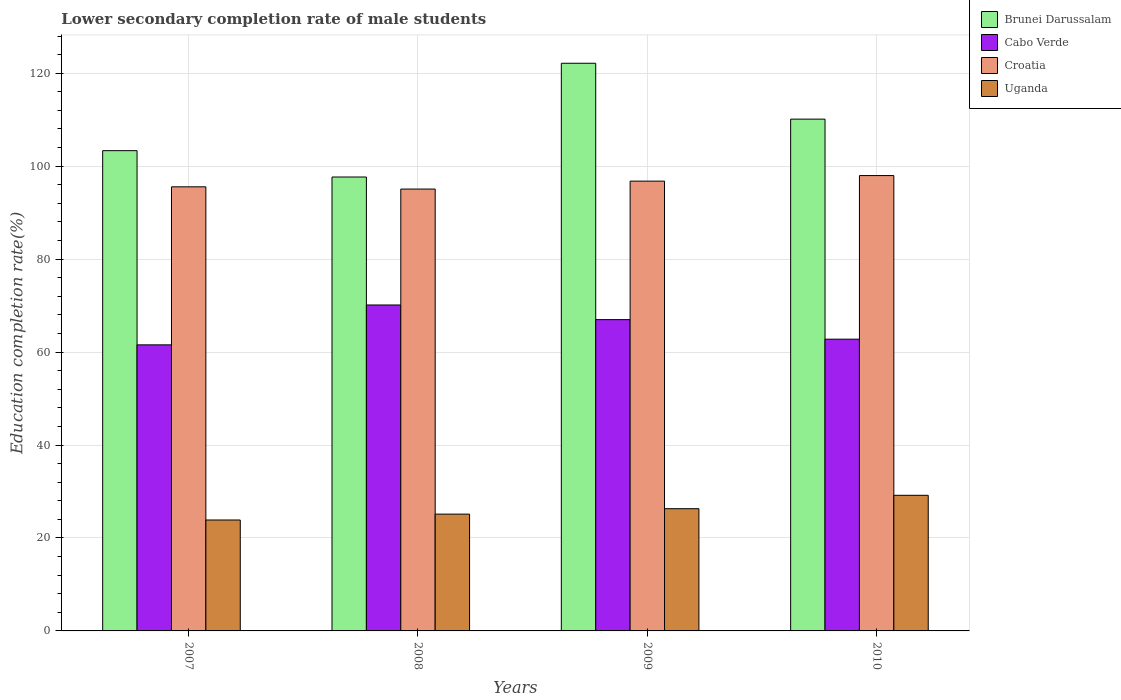Are the number of bars on each tick of the X-axis equal?
Keep it short and to the point. Yes. What is the lower secondary completion rate of male students in Cabo Verde in 2009?
Give a very brief answer. 66.98. Across all years, what is the maximum lower secondary completion rate of male students in Cabo Verde?
Offer a terse response. 70.13. Across all years, what is the minimum lower secondary completion rate of male students in Croatia?
Make the answer very short. 95.08. In which year was the lower secondary completion rate of male students in Uganda maximum?
Your answer should be very brief. 2010. In which year was the lower secondary completion rate of male students in Croatia minimum?
Your answer should be compact. 2008. What is the total lower secondary completion rate of male students in Croatia in the graph?
Your answer should be very brief. 385.39. What is the difference between the lower secondary completion rate of male students in Cabo Verde in 2007 and that in 2008?
Offer a very short reply. -8.58. What is the difference between the lower secondary completion rate of male students in Cabo Verde in 2010 and the lower secondary completion rate of male students in Brunei Darussalam in 2009?
Your answer should be compact. -59.37. What is the average lower secondary completion rate of male students in Cabo Verde per year?
Make the answer very short. 65.36. In the year 2010, what is the difference between the lower secondary completion rate of male students in Cabo Verde and lower secondary completion rate of male students in Croatia?
Offer a terse response. -35.2. What is the ratio of the lower secondary completion rate of male students in Brunei Darussalam in 2007 to that in 2010?
Keep it short and to the point. 0.94. What is the difference between the highest and the second highest lower secondary completion rate of male students in Uganda?
Provide a succinct answer. 2.88. What is the difference between the highest and the lowest lower secondary completion rate of male students in Cabo Verde?
Provide a short and direct response. 8.58. Is it the case that in every year, the sum of the lower secondary completion rate of male students in Uganda and lower secondary completion rate of male students in Croatia is greater than the sum of lower secondary completion rate of male students in Brunei Darussalam and lower secondary completion rate of male students in Cabo Verde?
Provide a succinct answer. No. What does the 3rd bar from the left in 2007 represents?
Offer a very short reply. Croatia. What does the 3rd bar from the right in 2010 represents?
Provide a succinct answer. Cabo Verde. Is it the case that in every year, the sum of the lower secondary completion rate of male students in Cabo Verde and lower secondary completion rate of male students in Croatia is greater than the lower secondary completion rate of male students in Uganda?
Your answer should be compact. Yes. How many bars are there?
Provide a succinct answer. 16. What is the difference between two consecutive major ticks on the Y-axis?
Ensure brevity in your answer.  20. Are the values on the major ticks of Y-axis written in scientific E-notation?
Your response must be concise. No. Does the graph contain grids?
Provide a short and direct response. Yes. How many legend labels are there?
Your answer should be compact. 4. What is the title of the graph?
Your answer should be very brief. Lower secondary completion rate of male students. What is the label or title of the X-axis?
Your answer should be compact. Years. What is the label or title of the Y-axis?
Make the answer very short. Education completion rate(%). What is the Education completion rate(%) in Brunei Darussalam in 2007?
Provide a short and direct response. 103.34. What is the Education completion rate(%) of Cabo Verde in 2007?
Offer a terse response. 61.55. What is the Education completion rate(%) of Croatia in 2007?
Offer a terse response. 95.56. What is the Education completion rate(%) of Uganda in 2007?
Give a very brief answer. 23.87. What is the Education completion rate(%) in Brunei Darussalam in 2008?
Your answer should be compact. 97.67. What is the Education completion rate(%) in Cabo Verde in 2008?
Ensure brevity in your answer.  70.13. What is the Education completion rate(%) in Croatia in 2008?
Provide a succinct answer. 95.08. What is the Education completion rate(%) in Uganda in 2008?
Keep it short and to the point. 25.13. What is the Education completion rate(%) in Brunei Darussalam in 2009?
Keep it short and to the point. 122.14. What is the Education completion rate(%) in Cabo Verde in 2009?
Ensure brevity in your answer.  66.98. What is the Education completion rate(%) of Croatia in 2009?
Provide a short and direct response. 96.78. What is the Education completion rate(%) of Uganda in 2009?
Your answer should be compact. 26.3. What is the Education completion rate(%) in Brunei Darussalam in 2010?
Offer a terse response. 110.12. What is the Education completion rate(%) of Cabo Verde in 2010?
Your answer should be compact. 62.77. What is the Education completion rate(%) in Croatia in 2010?
Offer a terse response. 97.98. What is the Education completion rate(%) of Uganda in 2010?
Offer a terse response. 29.18. Across all years, what is the maximum Education completion rate(%) of Brunei Darussalam?
Provide a short and direct response. 122.14. Across all years, what is the maximum Education completion rate(%) of Cabo Verde?
Give a very brief answer. 70.13. Across all years, what is the maximum Education completion rate(%) in Croatia?
Your answer should be compact. 97.98. Across all years, what is the maximum Education completion rate(%) in Uganda?
Provide a succinct answer. 29.18. Across all years, what is the minimum Education completion rate(%) in Brunei Darussalam?
Ensure brevity in your answer.  97.67. Across all years, what is the minimum Education completion rate(%) in Cabo Verde?
Your response must be concise. 61.55. Across all years, what is the minimum Education completion rate(%) in Croatia?
Your response must be concise. 95.08. Across all years, what is the minimum Education completion rate(%) in Uganda?
Offer a very short reply. 23.87. What is the total Education completion rate(%) of Brunei Darussalam in the graph?
Offer a terse response. 433.27. What is the total Education completion rate(%) in Cabo Verde in the graph?
Offer a terse response. 261.45. What is the total Education completion rate(%) of Croatia in the graph?
Give a very brief answer. 385.39. What is the total Education completion rate(%) in Uganda in the graph?
Provide a succinct answer. 104.48. What is the difference between the Education completion rate(%) of Brunei Darussalam in 2007 and that in 2008?
Make the answer very short. 5.67. What is the difference between the Education completion rate(%) in Cabo Verde in 2007 and that in 2008?
Provide a short and direct response. -8.58. What is the difference between the Education completion rate(%) of Croatia in 2007 and that in 2008?
Offer a terse response. 0.48. What is the difference between the Education completion rate(%) in Uganda in 2007 and that in 2008?
Keep it short and to the point. -1.26. What is the difference between the Education completion rate(%) in Brunei Darussalam in 2007 and that in 2009?
Give a very brief answer. -18.81. What is the difference between the Education completion rate(%) of Cabo Verde in 2007 and that in 2009?
Your answer should be compact. -5.43. What is the difference between the Education completion rate(%) of Croatia in 2007 and that in 2009?
Ensure brevity in your answer.  -1.23. What is the difference between the Education completion rate(%) in Uganda in 2007 and that in 2009?
Offer a very short reply. -2.43. What is the difference between the Education completion rate(%) in Brunei Darussalam in 2007 and that in 2010?
Keep it short and to the point. -6.78. What is the difference between the Education completion rate(%) in Cabo Verde in 2007 and that in 2010?
Your answer should be very brief. -1.22. What is the difference between the Education completion rate(%) of Croatia in 2007 and that in 2010?
Your answer should be compact. -2.42. What is the difference between the Education completion rate(%) in Uganda in 2007 and that in 2010?
Your answer should be compact. -5.31. What is the difference between the Education completion rate(%) in Brunei Darussalam in 2008 and that in 2009?
Your response must be concise. -24.48. What is the difference between the Education completion rate(%) in Cabo Verde in 2008 and that in 2009?
Give a very brief answer. 3.15. What is the difference between the Education completion rate(%) of Croatia in 2008 and that in 2009?
Give a very brief answer. -1.71. What is the difference between the Education completion rate(%) in Uganda in 2008 and that in 2009?
Ensure brevity in your answer.  -1.16. What is the difference between the Education completion rate(%) of Brunei Darussalam in 2008 and that in 2010?
Ensure brevity in your answer.  -12.45. What is the difference between the Education completion rate(%) of Cabo Verde in 2008 and that in 2010?
Ensure brevity in your answer.  7.36. What is the difference between the Education completion rate(%) in Croatia in 2008 and that in 2010?
Make the answer very short. -2.9. What is the difference between the Education completion rate(%) of Uganda in 2008 and that in 2010?
Provide a short and direct response. -4.05. What is the difference between the Education completion rate(%) in Brunei Darussalam in 2009 and that in 2010?
Ensure brevity in your answer.  12.02. What is the difference between the Education completion rate(%) in Cabo Verde in 2009 and that in 2010?
Give a very brief answer. 4.21. What is the difference between the Education completion rate(%) of Croatia in 2009 and that in 2010?
Ensure brevity in your answer.  -1.19. What is the difference between the Education completion rate(%) in Uganda in 2009 and that in 2010?
Offer a very short reply. -2.88. What is the difference between the Education completion rate(%) in Brunei Darussalam in 2007 and the Education completion rate(%) in Cabo Verde in 2008?
Provide a succinct answer. 33.2. What is the difference between the Education completion rate(%) of Brunei Darussalam in 2007 and the Education completion rate(%) of Croatia in 2008?
Keep it short and to the point. 8.26. What is the difference between the Education completion rate(%) of Brunei Darussalam in 2007 and the Education completion rate(%) of Uganda in 2008?
Make the answer very short. 78.2. What is the difference between the Education completion rate(%) of Cabo Verde in 2007 and the Education completion rate(%) of Croatia in 2008?
Provide a succinct answer. -33.52. What is the difference between the Education completion rate(%) in Cabo Verde in 2007 and the Education completion rate(%) in Uganda in 2008?
Ensure brevity in your answer.  36.42. What is the difference between the Education completion rate(%) of Croatia in 2007 and the Education completion rate(%) of Uganda in 2008?
Offer a terse response. 70.42. What is the difference between the Education completion rate(%) of Brunei Darussalam in 2007 and the Education completion rate(%) of Cabo Verde in 2009?
Your answer should be very brief. 36.35. What is the difference between the Education completion rate(%) of Brunei Darussalam in 2007 and the Education completion rate(%) of Croatia in 2009?
Your answer should be very brief. 6.56. What is the difference between the Education completion rate(%) of Brunei Darussalam in 2007 and the Education completion rate(%) of Uganda in 2009?
Make the answer very short. 77.04. What is the difference between the Education completion rate(%) in Cabo Verde in 2007 and the Education completion rate(%) in Croatia in 2009?
Your answer should be very brief. -35.23. What is the difference between the Education completion rate(%) in Cabo Verde in 2007 and the Education completion rate(%) in Uganda in 2009?
Offer a terse response. 35.26. What is the difference between the Education completion rate(%) in Croatia in 2007 and the Education completion rate(%) in Uganda in 2009?
Your answer should be very brief. 69.26. What is the difference between the Education completion rate(%) in Brunei Darussalam in 2007 and the Education completion rate(%) in Cabo Verde in 2010?
Offer a very short reply. 40.56. What is the difference between the Education completion rate(%) of Brunei Darussalam in 2007 and the Education completion rate(%) of Croatia in 2010?
Ensure brevity in your answer.  5.36. What is the difference between the Education completion rate(%) of Brunei Darussalam in 2007 and the Education completion rate(%) of Uganda in 2010?
Give a very brief answer. 74.16. What is the difference between the Education completion rate(%) of Cabo Verde in 2007 and the Education completion rate(%) of Croatia in 2010?
Offer a very short reply. -36.42. What is the difference between the Education completion rate(%) in Cabo Verde in 2007 and the Education completion rate(%) in Uganda in 2010?
Offer a very short reply. 32.37. What is the difference between the Education completion rate(%) of Croatia in 2007 and the Education completion rate(%) of Uganda in 2010?
Ensure brevity in your answer.  66.38. What is the difference between the Education completion rate(%) of Brunei Darussalam in 2008 and the Education completion rate(%) of Cabo Verde in 2009?
Keep it short and to the point. 30.68. What is the difference between the Education completion rate(%) of Brunei Darussalam in 2008 and the Education completion rate(%) of Croatia in 2009?
Your answer should be very brief. 0.89. What is the difference between the Education completion rate(%) of Brunei Darussalam in 2008 and the Education completion rate(%) of Uganda in 2009?
Provide a short and direct response. 71.37. What is the difference between the Education completion rate(%) of Cabo Verde in 2008 and the Education completion rate(%) of Croatia in 2009?
Your answer should be compact. -26.65. What is the difference between the Education completion rate(%) of Cabo Verde in 2008 and the Education completion rate(%) of Uganda in 2009?
Provide a short and direct response. 43.83. What is the difference between the Education completion rate(%) of Croatia in 2008 and the Education completion rate(%) of Uganda in 2009?
Provide a short and direct response. 68.78. What is the difference between the Education completion rate(%) of Brunei Darussalam in 2008 and the Education completion rate(%) of Cabo Verde in 2010?
Provide a succinct answer. 34.89. What is the difference between the Education completion rate(%) of Brunei Darussalam in 2008 and the Education completion rate(%) of Croatia in 2010?
Keep it short and to the point. -0.31. What is the difference between the Education completion rate(%) of Brunei Darussalam in 2008 and the Education completion rate(%) of Uganda in 2010?
Keep it short and to the point. 68.49. What is the difference between the Education completion rate(%) in Cabo Verde in 2008 and the Education completion rate(%) in Croatia in 2010?
Your response must be concise. -27.84. What is the difference between the Education completion rate(%) in Cabo Verde in 2008 and the Education completion rate(%) in Uganda in 2010?
Make the answer very short. 40.95. What is the difference between the Education completion rate(%) of Croatia in 2008 and the Education completion rate(%) of Uganda in 2010?
Give a very brief answer. 65.9. What is the difference between the Education completion rate(%) in Brunei Darussalam in 2009 and the Education completion rate(%) in Cabo Verde in 2010?
Make the answer very short. 59.37. What is the difference between the Education completion rate(%) of Brunei Darussalam in 2009 and the Education completion rate(%) of Croatia in 2010?
Ensure brevity in your answer.  24.17. What is the difference between the Education completion rate(%) of Brunei Darussalam in 2009 and the Education completion rate(%) of Uganda in 2010?
Provide a succinct answer. 92.96. What is the difference between the Education completion rate(%) in Cabo Verde in 2009 and the Education completion rate(%) in Croatia in 2010?
Your response must be concise. -30.99. What is the difference between the Education completion rate(%) of Cabo Verde in 2009 and the Education completion rate(%) of Uganda in 2010?
Your answer should be very brief. 37.8. What is the difference between the Education completion rate(%) of Croatia in 2009 and the Education completion rate(%) of Uganda in 2010?
Ensure brevity in your answer.  67.6. What is the average Education completion rate(%) of Brunei Darussalam per year?
Provide a short and direct response. 108.32. What is the average Education completion rate(%) of Cabo Verde per year?
Your response must be concise. 65.36. What is the average Education completion rate(%) of Croatia per year?
Keep it short and to the point. 96.35. What is the average Education completion rate(%) in Uganda per year?
Provide a short and direct response. 26.12. In the year 2007, what is the difference between the Education completion rate(%) in Brunei Darussalam and Education completion rate(%) in Cabo Verde?
Provide a succinct answer. 41.78. In the year 2007, what is the difference between the Education completion rate(%) in Brunei Darussalam and Education completion rate(%) in Croatia?
Keep it short and to the point. 7.78. In the year 2007, what is the difference between the Education completion rate(%) in Brunei Darussalam and Education completion rate(%) in Uganda?
Give a very brief answer. 79.47. In the year 2007, what is the difference between the Education completion rate(%) in Cabo Verde and Education completion rate(%) in Croatia?
Ensure brevity in your answer.  -34. In the year 2007, what is the difference between the Education completion rate(%) of Cabo Verde and Education completion rate(%) of Uganda?
Your response must be concise. 37.69. In the year 2007, what is the difference between the Education completion rate(%) of Croatia and Education completion rate(%) of Uganda?
Offer a terse response. 71.69. In the year 2008, what is the difference between the Education completion rate(%) in Brunei Darussalam and Education completion rate(%) in Cabo Verde?
Make the answer very short. 27.53. In the year 2008, what is the difference between the Education completion rate(%) in Brunei Darussalam and Education completion rate(%) in Croatia?
Keep it short and to the point. 2.59. In the year 2008, what is the difference between the Education completion rate(%) in Brunei Darussalam and Education completion rate(%) in Uganda?
Ensure brevity in your answer.  72.53. In the year 2008, what is the difference between the Education completion rate(%) in Cabo Verde and Education completion rate(%) in Croatia?
Offer a very short reply. -24.94. In the year 2008, what is the difference between the Education completion rate(%) of Cabo Verde and Education completion rate(%) of Uganda?
Keep it short and to the point. 45. In the year 2008, what is the difference between the Education completion rate(%) of Croatia and Education completion rate(%) of Uganda?
Ensure brevity in your answer.  69.94. In the year 2009, what is the difference between the Education completion rate(%) in Brunei Darussalam and Education completion rate(%) in Cabo Verde?
Keep it short and to the point. 55.16. In the year 2009, what is the difference between the Education completion rate(%) of Brunei Darussalam and Education completion rate(%) of Croatia?
Your response must be concise. 25.36. In the year 2009, what is the difference between the Education completion rate(%) of Brunei Darussalam and Education completion rate(%) of Uganda?
Offer a terse response. 95.85. In the year 2009, what is the difference between the Education completion rate(%) in Cabo Verde and Education completion rate(%) in Croatia?
Keep it short and to the point. -29.8. In the year 2009, what is the difference between the Education completion rate(%) of Cabo Verde and Education completion rate(%) of Uganda?
Keep it short and to the point. 40.68. In the year 2009, what is the difference between the Education completion rate(%) in Croatia and Education completion rate(%) in Uganda?
Provide a short and direct response. 70.48. In the year 2010, what is the difference between the Education completion rate(%) in Brunei Darussalam and Education completion rate(%) in Cabo Verde?
Keep it short and to the point. 47.35. In the year 2010, what is the difference between the Education completion rate(%) of Brunei Darussalam and Education completion rate(%) of Croatia?
Provide a succinct answer. 12.14. In the year 2010, what is the difference between the Education completion rate(%) of Brunei Darussalam and Education completion rate(%) of Uganda?
Your answer should be compact. 80.94. In the year 2010, what is the difference between the Education completion rate(%) in Cabo Verde and Education completion rate(%) in Croatia?
Give a very brief answer. -35.2. In the year 2010, what is the difference between the Education completion rate(%) of Cabo Verde and Education completion rate(%) of Uganda?
Make the answer very short. 33.59. In the year 2010, what is the difference between the Education completion rate(%) of Croatia and Education completion rate(%) of Uganda?
Provide a succinct answer. 68.8. What is the ratio of the Education completion rate(%) of Brunei Darussalam in 2007 to that in 2008?
Make the answer very short. 1.06. What is the ratio of the Education completion rate(%) in Cabo Verde in 2007 to that in 2008?
Keep it short and to the point. 0.88. What is the ratio of the Education completion rate(%) of Uganda in 2007 to that in 2008?
Provide a succinct answer. 0.95. What is the ratio of the Education completion rate(%) of Brunei Darussalam in 2007 to that in 2009?
Your answer should be compact. 0.85. What is the ratio of the Education completion rate(%) in Cabo Verde in 2007 to that in 2009?
Offer a very short reply. 0.92. What is the ratio of the Education completion rate(%) of Croatia in 2007 to that in 2009?
Offer a very short reply. 0.99. What is the ratio of the Education completion rate(%) of Uganda in 2007 to that in 2009?
Give a very brief answer. 0.91. What is the ratio of the Education completion rate(%) in Brunei Darussalam in 2007 to that in 2010?
Provide a succinct answer. 0.94. What is the ratio of the Education completion rate(%) of Cabo Verde in 2007 to that in 2010?
Your answer should be very brief. 0.98. What is the ratio of the Education completion rate(%) of Croatia in 2007 to that in 2010?
Offer a very short reply. 0.98. What is the ratio of the Education completion rate(%) in Uganda in 2007 to that in 2010?
Ensure brevity in your answer.  0.82. What is the ratio of the Education completion rate(%) of Brunei Darussalam in 2008 to that in 2009?
Keep it short and to the point. 0.8. What is the ratio of the Education completion rate(%) in Cabo Verde in 2008 to that in 2009?
Ensure brevity in your answer.  1.05. What is the ratio of the Education completion rate(%) of Croatia in 2008 to that in 2009?
Your response must be concise. 0.98. What is the ratio of the Education completion rate(%) of Uganda in 2008 to that in 2009?
Ensure brevity in your answer.  0.96. What is the ratio of the Education completion rate(%) of Brunei Darussalam in 2008 to that in 2010?
Provide a short and direct response. 0.89. What is the ratio of the Education completion rate(%) in Cabo Verde in 2008 to that in 2010?
Your answer should be very brief. 1.12. What is the ratio of the Education completion rate(%) of Croatia in 2008 to that in 2010?
Your answer should be compact. 0.97. What is the ratio of the Education completion rate(%) in Uganda in 2008 to that in 2010?
Make the answer very short. 0.86. What is the ratio of the Education completion rate(%) of Brunei Darussalam in 2009 to that in 2010?
Your answer should be compact. 1.11. What is the ratio of the Education completion rate(%) in Cabo Verde in 2009 to that in 2010?
Offer a very short reply. 1.07. What is the ratio of the Education completion rate(%) of Croatia in 2009 to that in 2010?
Keep it short and to the point. 0.99. What is the ratio of the Education completion rate(%) in Uganda in 2009 to that in 2010?
Offer a terse response. 0.9. What is the difference between the highest and the second highest Education completion rate(%) of Brunei Darussalam?
Offer a terse response. 12.02. What is the difference between the highest and the second highest Education completion rate(%) in Cabo Verde?
Keep it short and to the point. 3.15. What is the difference between the highest and the second highest Education completion rate(%) in Croatia?
Your answer should be very brief. 1.19. What is the difference between the highest and the second highest Education completion rate(%) of Uganda?
Ensure brevity in your answer.  2.88. What is the difference between the highest and the lowest Education completion rate(%) of Brunei Darussalam?
Ensure brevity in your answer.  24.48. What is the difference between the highest and the lowest Education completion rate(%) in Cabo Verde?
Provide a short and direct response. 8.58. What is the difference between the highest and the lowest Education completion rate(%) of Croatia?
Your answer should be very brief. 2.9. What is the difference between the highest and the lowest Education completion rate(%) in Uganda?
Provide a short and direct response. 5.31. 